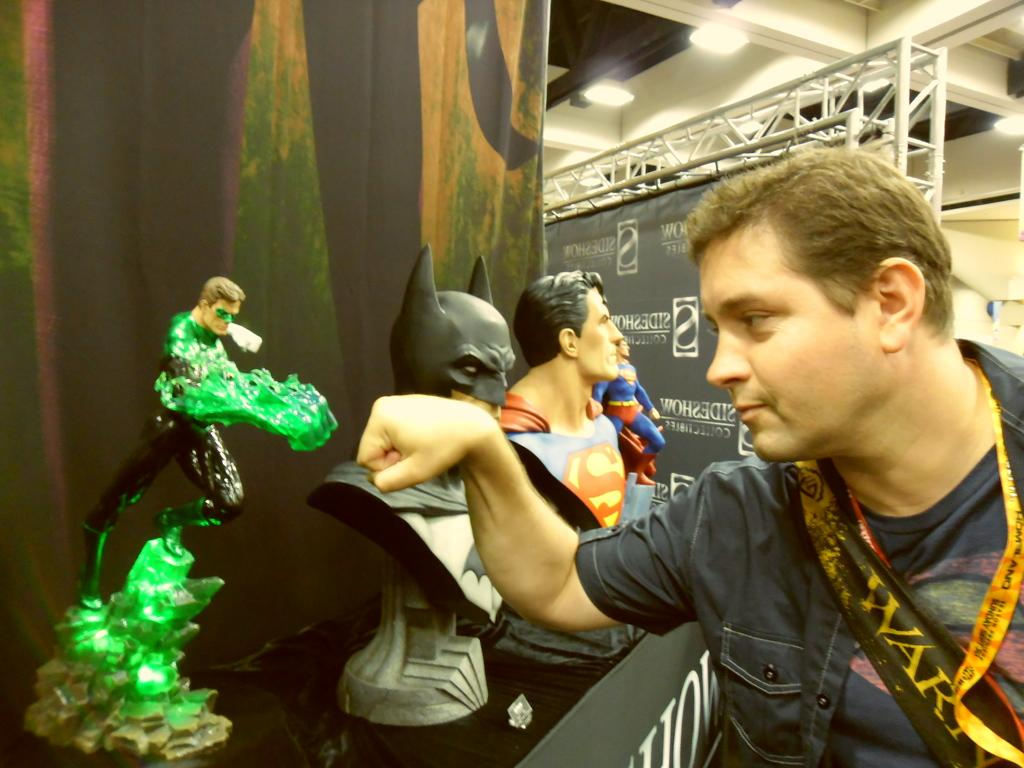What is the person in the image looking at? The person is looking at a toy. What is the surface on which the toys are placed? The toys are on a black surface. What can be seen in the background of the image? There is a hoarding and lights in the background. How many passengers are visible in the image? There are no passengers present in the image, as it only features a person looking at a toy. What type of girls are playing with the toys in the image? There are no girls present in the image; it only features a person looking at a toy on a black surface with a hoarding and lights in the background. 